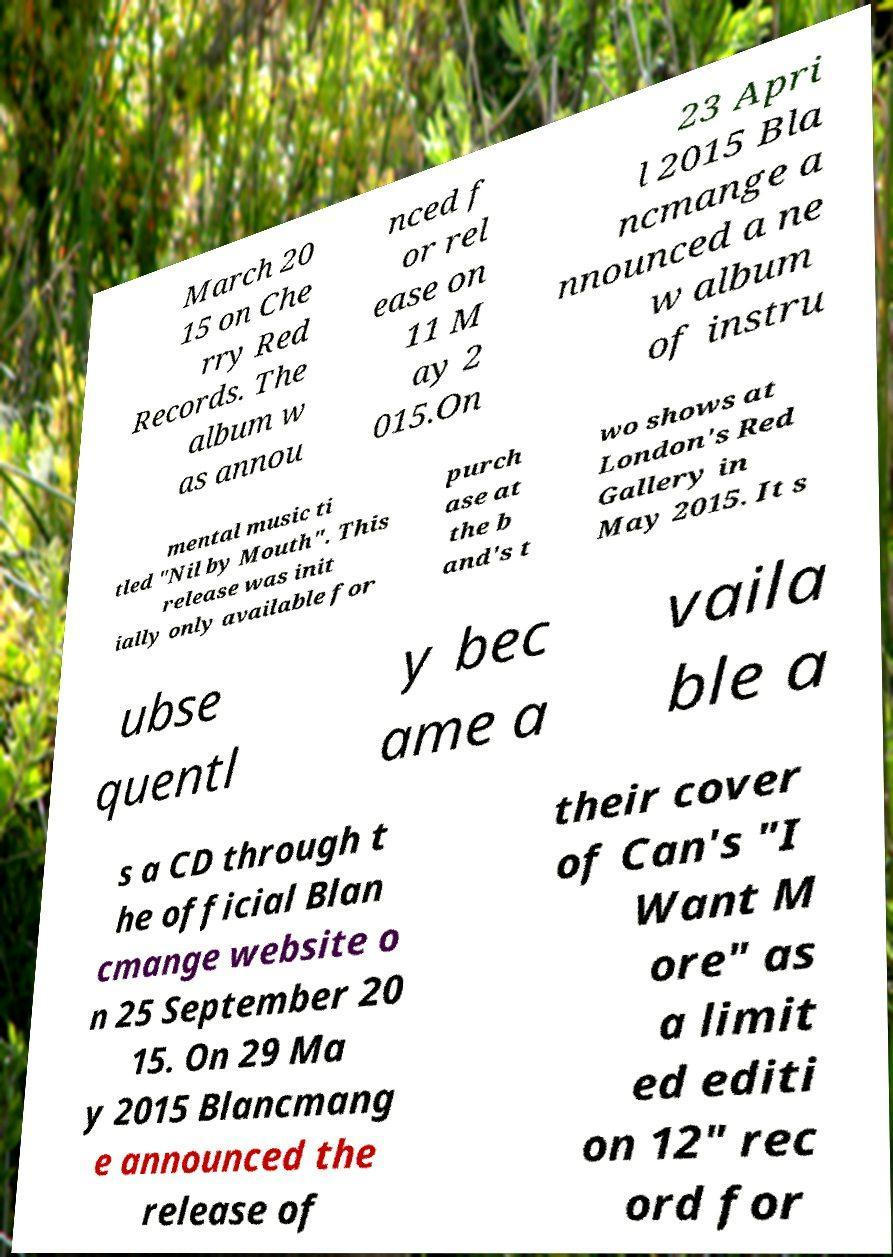There's text embedded in this image that I need extracted. Can you transcribe it verbatim? March 20 15 on Che rry Red Records. The album w as annou nced f or rel ease on 11 M ay 2 015.On 23 Apri l 2015 Bla ncmange a nnounced a ne w album of instru mental music ti tled "Nil by Mouth". This release was init ially only available for purch ase at the b and's t wo shows at London's Red Gallery in May 2015. It s ubse quentl y bec ame a vaila ble a s a CD through t he official Blan cmange website o n 25 September 20 15. On 29 Ma y 2015 Blancmang e announced the release of their cover of Can's "I Want M ore" as a limit ed editi on 12" rec ord for 